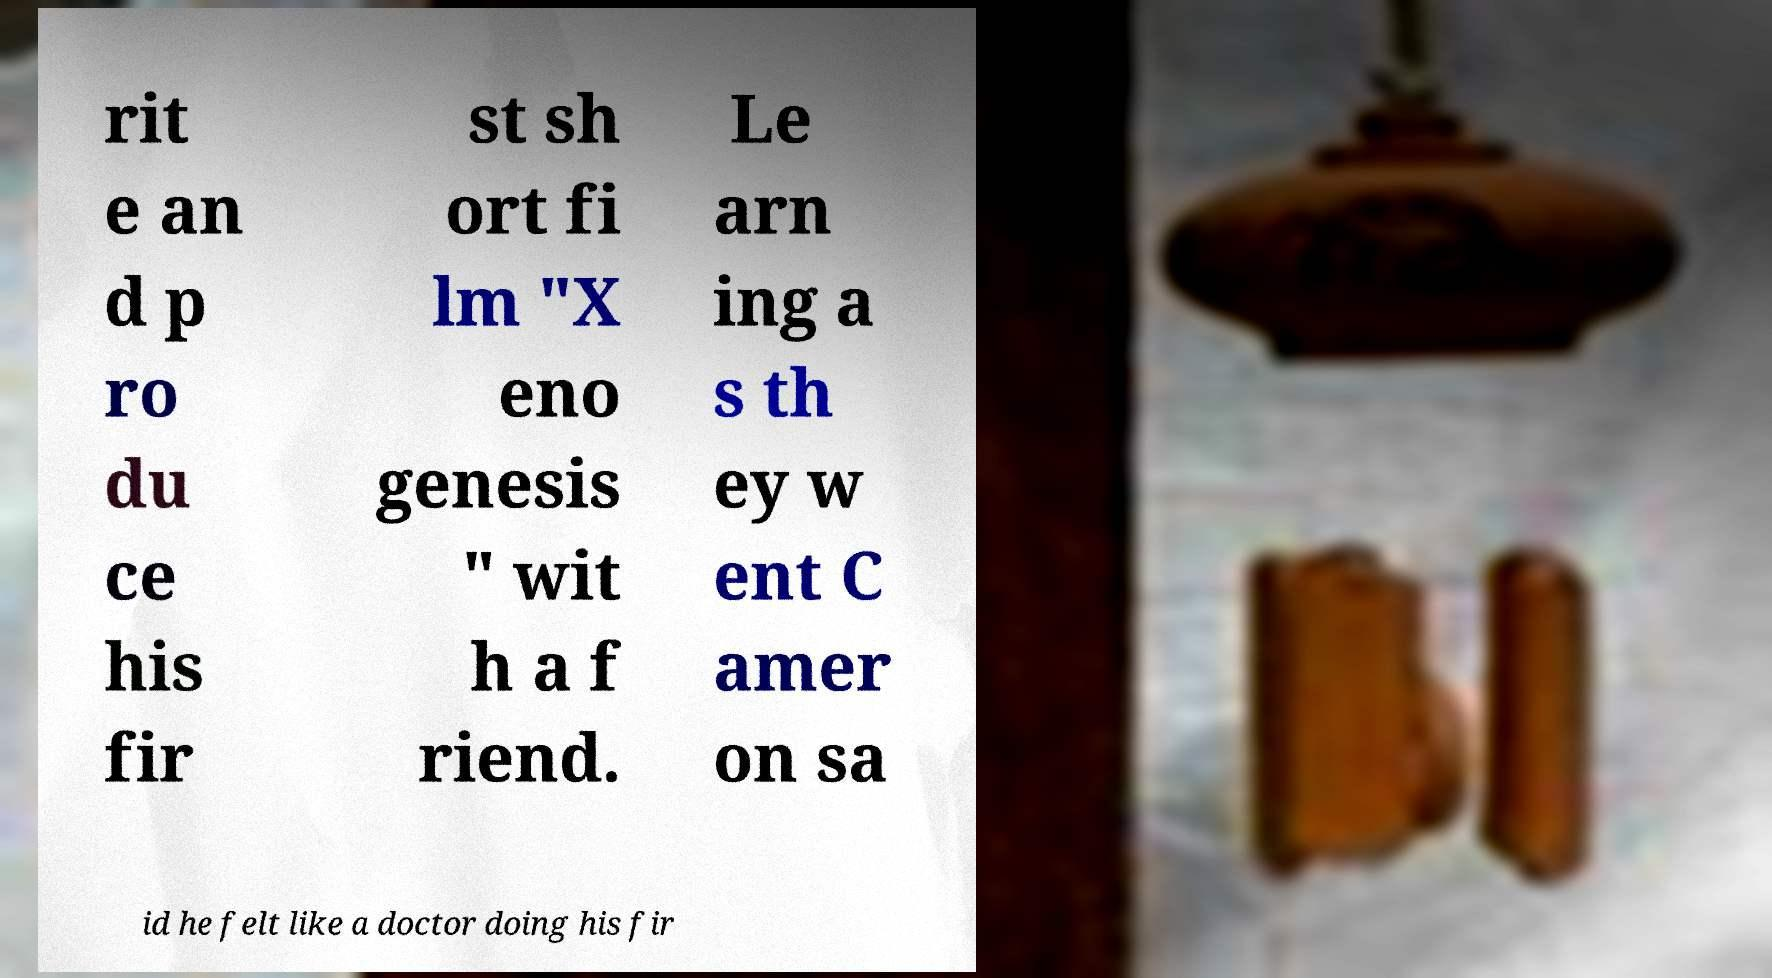For documentation purposes, I need the text within this image transcribed. Could you provide that? rit e an d p ro du ce his fir st sh ort fi lm "X eno genesis " wit h a f riend. Le arn ing a s th ey w ent C amer on sa id he felt like a doctor doing his fir 